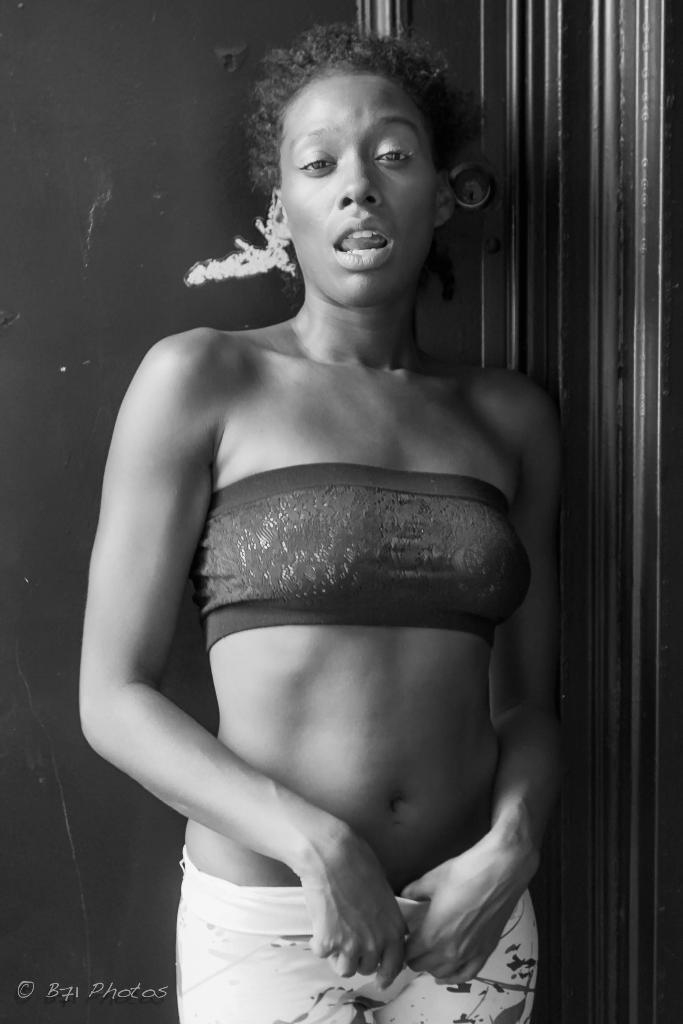How would you summarize this image in a sentence or two? In this picture we can observe a woman standing. Behind her there is a wall. We can observe watermark on the left side of this picture. This is a black and white image. 